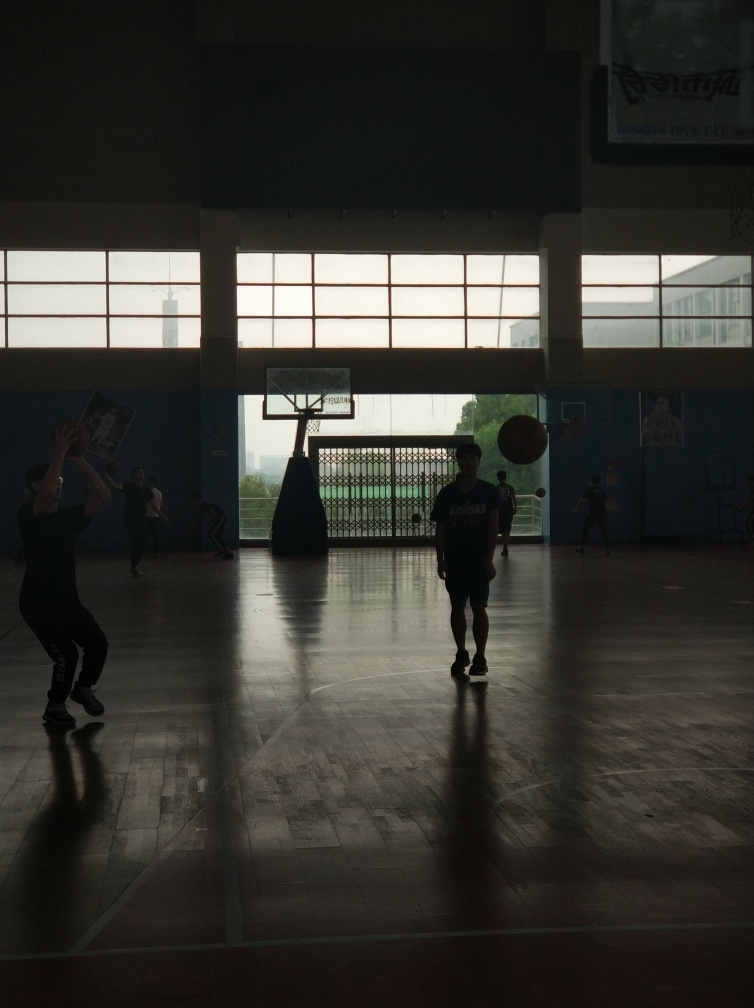Can you describe the ambiance of the location shown in this image? The image depicts an indoor basketball court with a serene and focused atmosphere. The natural lighting from the windows contrasts with the darker interior, creating a dramatic and somewhat contemplative environment. What action is taking place in the image? There are two individuals actively engaged in playing basketball. One person is shooting the ball toward the basket, while the other appears to be preparing for a potential rebound or to play defense. 